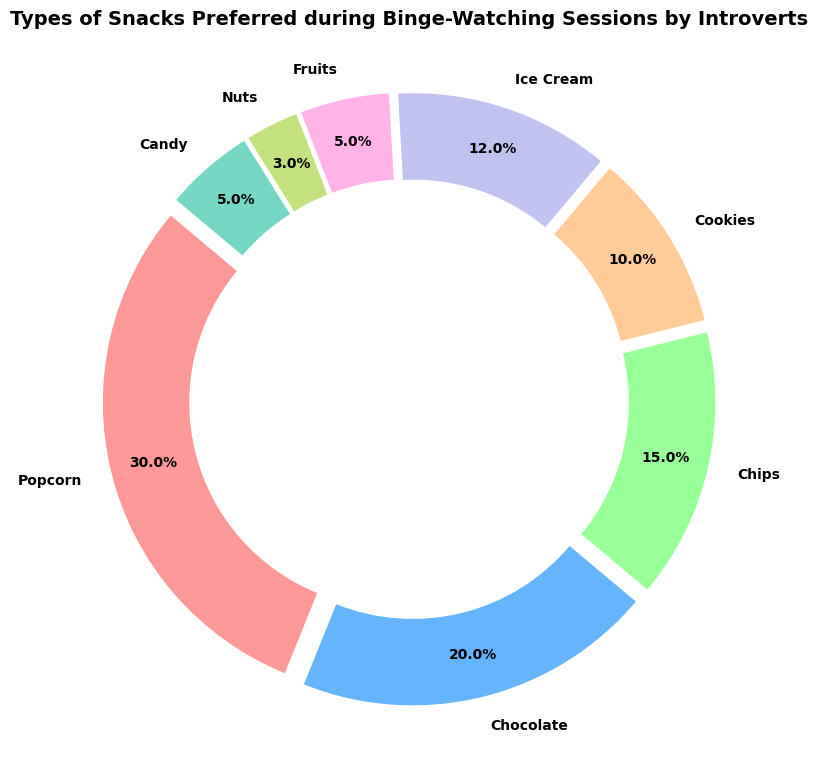What’s the most popular snack among introverts during binge-watching sessions? The ring chart shows the percentage distributions of different snacks. By identifying the largest segment, we see that Popcorn has the highest percentage at 30%.
Answer: Popcorn Which snack is least preferred by introverts during binge-watching sessions? The least preferred snack will be represented by the smallest segment in the chart. From the figure, Nuts have the smallest segment at 3%.
Answer: Nuts How do the percentages of Cookies and Ice Cream compare? From the ring chart, Cookies have a 10% share while Ice Cream has a 12% share. Comparing these: 10% < 12%.
Answer: Ice Cream is more preferred than Cookies What’s the total percentage for savory snacks (Popcorn, Chips, and Nuts)? Add the percentages of Popcorn (30%), Chips (15%), and Nuts (3%). The total is 30% + 15% + 3% = 48%.
Answer: 48% What is the difference in percentage points between the most and least preferred snacks? The most preferred snack is Popcorn at 30%, and the least preferred is Nuts at 3%. The difference is 30% - 3% = 27 percentage points.
Answer: 27 percentage points What percentage of introverts prefer sweet snacks (Chocolate, Ice Cream, Candy)? Add the percentages of Chocolate (20%), Ice Cream (12%), and Candy (5%). The total is 20% + 12% + 5% = 37%.
Answer: 37% Which snack type has a percentage close to 10%, and what is it exactly? By observing the chart, Cookies have a percentage very close to 10%. The chart confirms that it's exactly 10%.
Answer: Cookies, 10% Is the combined preference for Fruits and Candy greater or lesser than for Ice Cream? The combination for Fruits (5%) and Candy (5%) is 5% + 5% = 10%. Ice Cream alone is 12%. Since 10% < 12%, the combined preference is lesser.
Answer: Lesser What’s the visual difference between the segments for Chocolate and Chips? Visually, Chocolate has a larger segment (20%) compared to Chips (15%). Look at the width or arc length of the respective segments to compare them visually.
Answer: Chocolate has a larger segment By how many percentage points does Fruit's preference differ from Candy's preference? Both Fruits and Candy have percentages of 5%. The difference is 5% - 5% = 0 percentage points.
Answer: 0 percentage points 